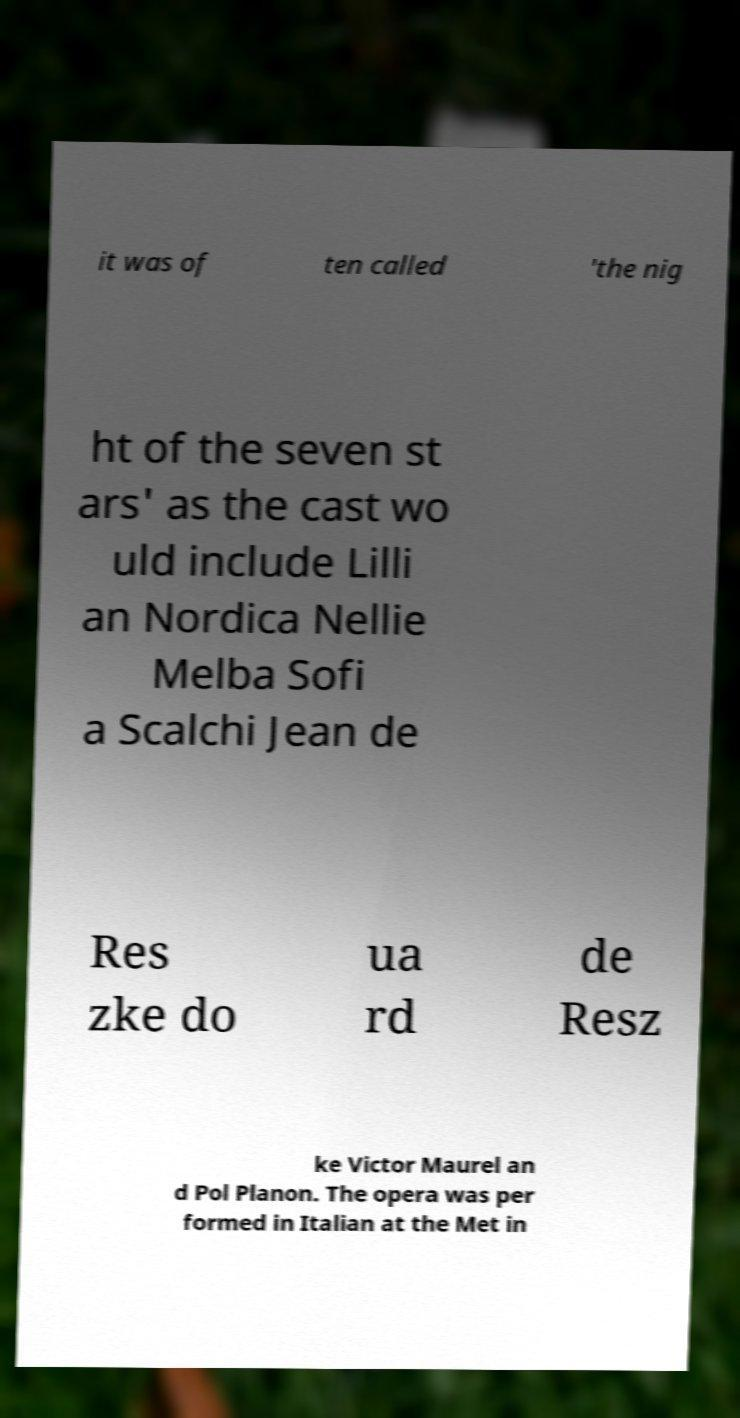Please read and relay the text visible in this image. What does it say? it was of ten called 'the nig ht of the seven st ars' as the cast wo uld include Lilli an Nordica Nellie Melba Sofi a Scalchi Jean de Res zke do ua rd de Resz ke Victor Maurel an d Pol Planon. The opera was per formed in Italian at the Met in 